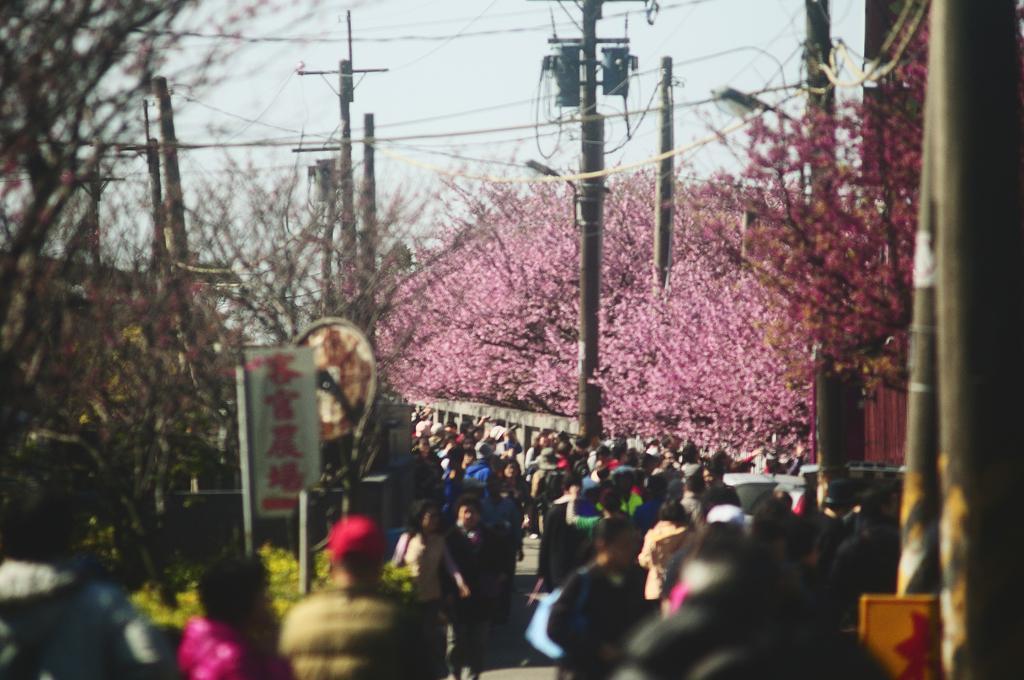In one or two sentences, can you explain what this image depicts? In this picture we can see a group of people on the road, poles, trees, banner and some objects and in the background we can see the sky. 